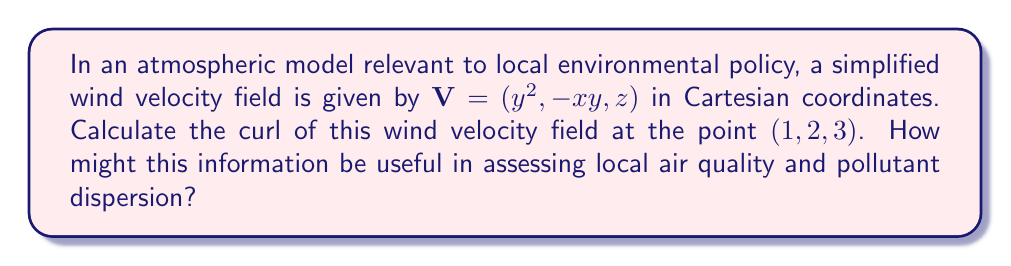Teach me how to tackle this problem. To solve this problem, we'll follow these steps:

1) The curl of a vector field $\mathbf{V} = (V_x, V_y, V_z)$ in Cartesian coordinates is given by:

   $$\text{curl }\mathbf{V} = \nabla \times \mathbf{V} = \left(\frac{\partial V_z}{\partial y} - \frac{\partial V_y}{\partial z}, \frac{\partial V_x}{\partial z} - \frac{\partial V_z}{\partial x}, \frac{\partial V_y}{\partial x} - \frac{\partial V_x}{\partial y}\right)$$

2) For our given vector field $\mathbf{V} = (y^2, -xy, z)$:
   $V_x = y^2$
   $V_y = -xy$
   $V_z = z$

3) Let's calculate each partial derivative:
   $\frac{\partial V_z}{\partial y} = 0$
   $\frac{\partial V_y}{\partial z} = 0$
   $\frac{\partial V_x}{\partial z} = 0$
   $\frac{\partial V_z}{\partial x} = 0$
   $\frac{\partial V_y}{\partial x} = -y$
   $\frac{\partial V_x}{\partial y} = 2y$

4) Now we can calculate the curl:
   $$\text{curl }\mathbf{V} = (0 - 0, 0 - 0, -y - 2y) = (0, 0, -3y)$$

5) At the point $(1, 2, 3)$, $y = 2$, so:
   $$\text{curl }\mathbf{V}_{(1,2,3)} = (0, 0, -3(2)) = (0, 0, -6)$$

This curl indicates rotation in the wind field, which is crucial for understanding pollutant dispersion. A non-zero curl suggests areas of rotation or vorticity in the atmosphere. For environmental policy, this information can help predict how pollutants might concentrate or disperse in certain areas, informing decisions on emission regulations or air quality monitoring locations.
Answer: $(0, 0, -6)$ 